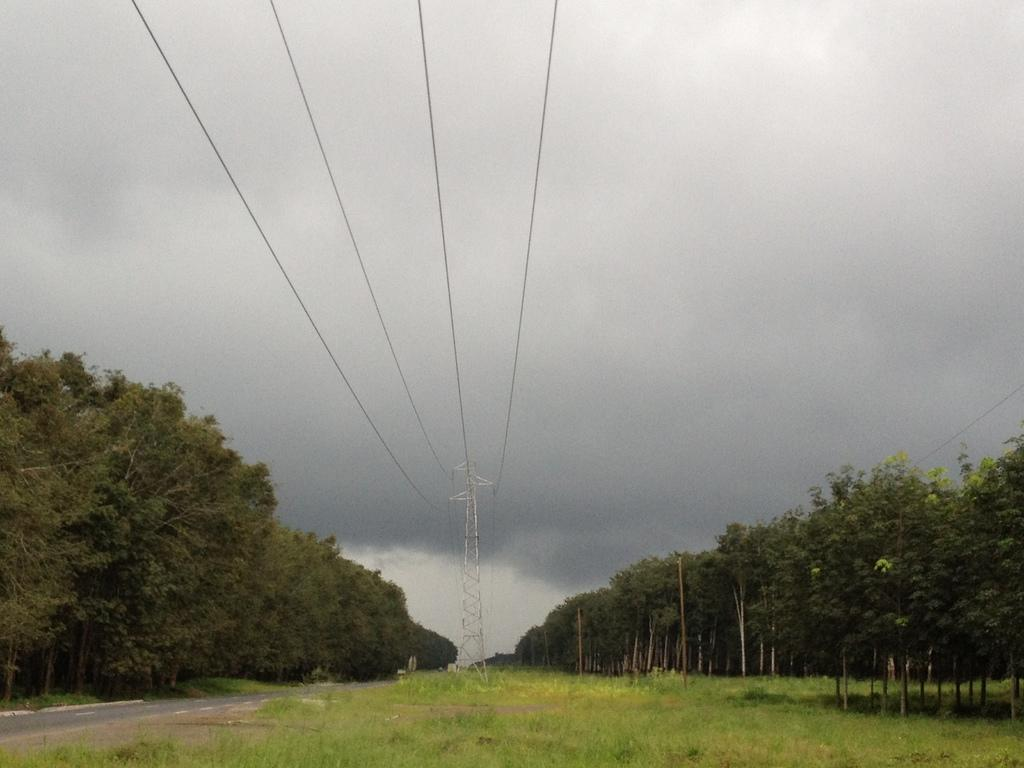What is the main feature of the image? There is a road in the image. What can be seen beside the road? Trees are visible beside the road. What type of vegetation is present in the image? Grass is present in the image. What else can be seen in the image related to infrastructure? There is an overhead power line in the image. What is visible in the background of the image? The sky is visible in the background of the image. What type of writing can be seen on the trees in the image? There is no writing visible on the trees in the image. Are there any bears present in the image? There are no bears present in the image. 